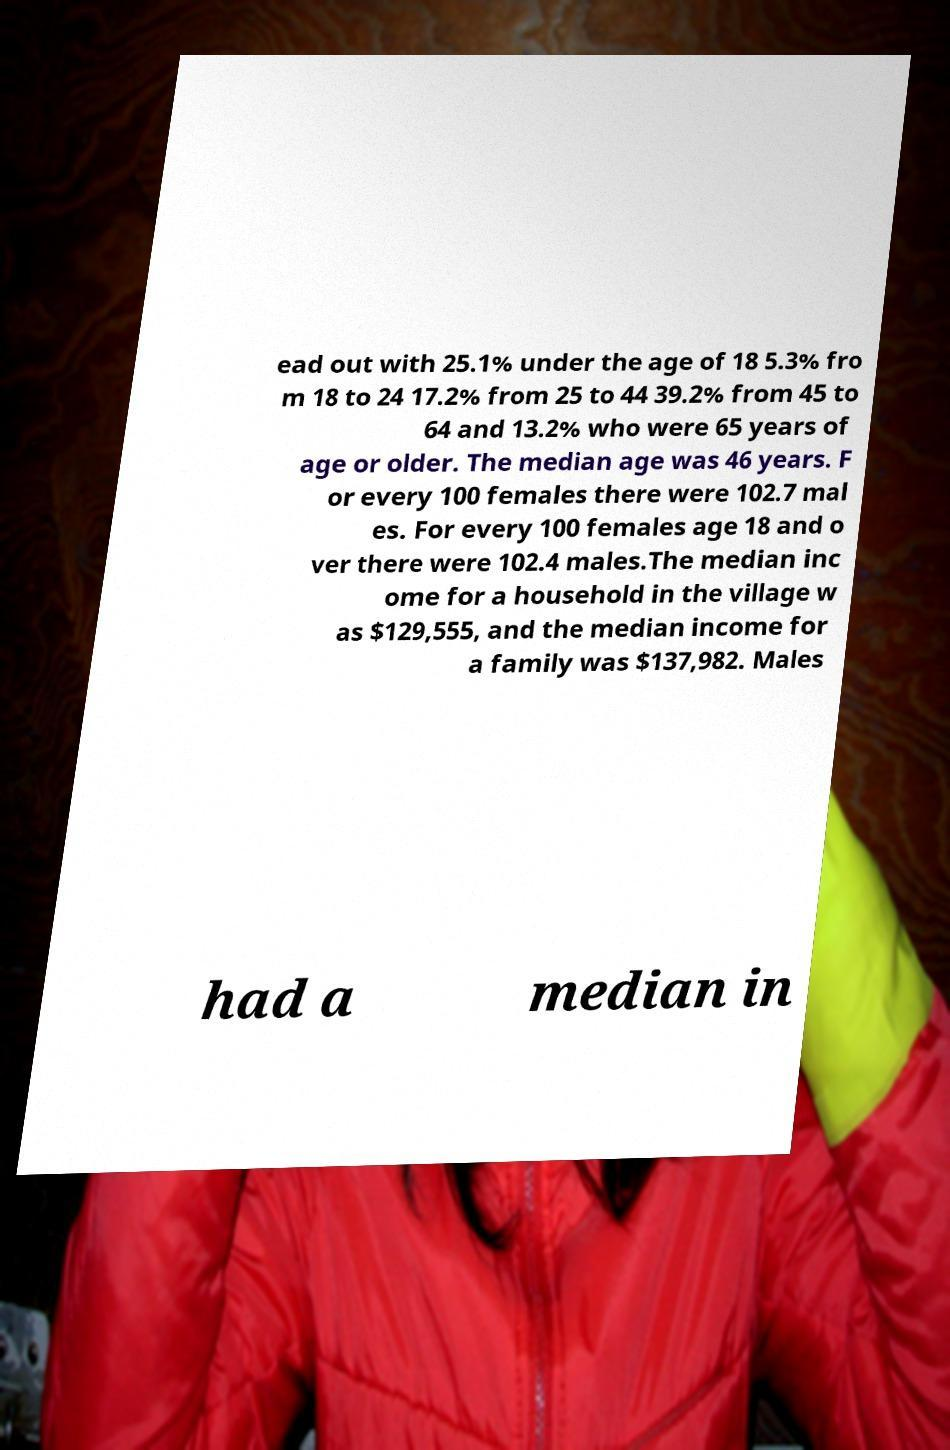I need the written content from this picture converted into text. Can you do that? ead out with 25.1% under the age of 18 5.3% fro m 18 to 24 17.2% from 25 to 44 39.2% from 45 to 64 and 13.2% who were 65 years of age or older. The median age was 46 years. F or every 100 females there were 102.7 mal es. For every 100 females age 18 and o ver there were 102.4 males.The median inc ome for a household in the village w as $129,555, and the median income for a family was $137,982. Males had a median in 